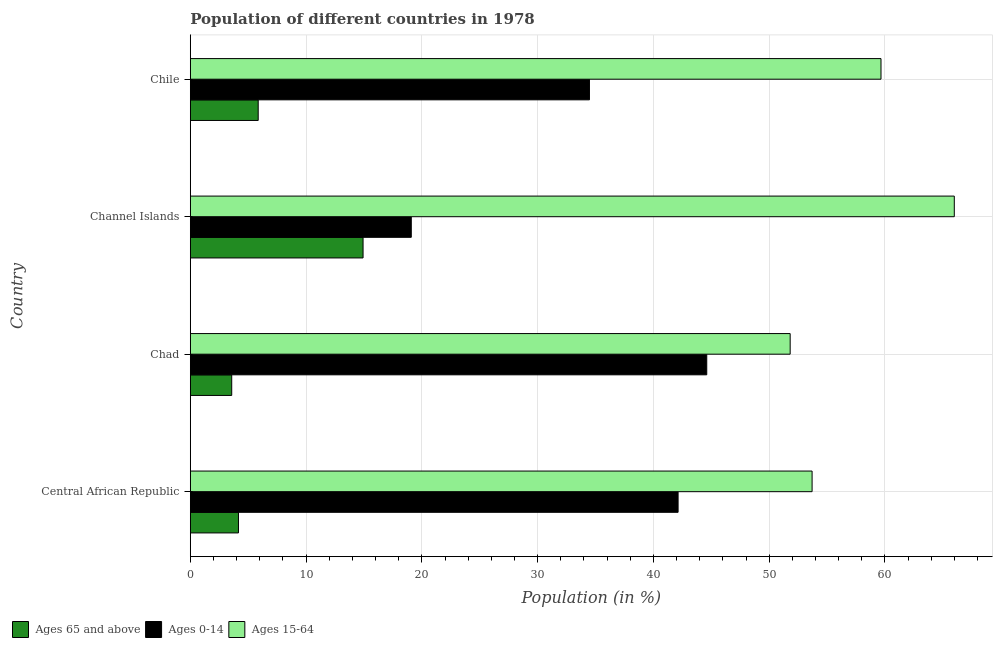How many different coloured bars are there?
Your response must be concise. 3. Are the number of bars per tick equal to the number of legend labels?
Provide a short and direct response. Yes. How many bars are there on the 1st tick from the bottom?
Give a very brief answer. 3. What is the label of the 4th group of bars from the top?
Keep it short and to the point. Central African Republic. In how many cases, is the number of bars for a given country not equal to the number of legend labels?
Make the answer very short. 0. What is the percentage of population within the age-group 15-64 in Chad?
Offer a very short reply. 51.81. Across all countries, what is the maximum percentage of population within the age-group of 65 and above?
Make the answer very short. 14.92. Across all countries, what is the minimum percentage of population within the age-group 15-64?
Offer a terse response. 51.81. In which country was the percentage of population within the age-group of 65 and above maximum?
Offer a very short reply. Channel Islands. In which country was the percentage of population within the age-group of 65 and above minimum?
Offer a terse response. Chad. What is the total percentage of population within the age-group 15-64 in the graph?
Your response must be concise. 231.17. What is the difference between the percentage of population within the age-group 15-64 in Central African Republic and that in Chile?
Offer a terse response. -5.95. What is the difference between the percentage of population within the age-group of 65 and above in Channel Islands and the percentage of population within the age-group 0-14 in Chile?
Provide a short and direct response. -19.55. What is the average percentage of population within the age-group 15-64 per country?
Offer a terse response. 57.79. What is the difference between the percentage of population within the age-group of 65 and above and percentage of population within the age-group 0-14 in Chile?
Give a very brief answer. -28.61. In how many countries, is the percentage of population within the age-group of 65 and above greater than 24 %?
Provide a short and direct response. 0. Is the difference between the percentage of population within the age-group of 65 and above in Chad and Chile greater than the difference between the percentage of population within the age-group 15-64 in Chad and Chile?
Offer a terse response. Yes. What is the difference between the highest and the second highest percentage of population within the age-group of 65 and above?
Give a very brief answer. 9.06. What is the difference between the highest and the lowest percentage of population within the age-group 0-14?
Provide a succinct answer. 25.52. Is the sum of the percentage of population within the age-group 0-14 in Central African Republic and Chile greater than the maximum percentage of population within the age-group of 65 and above across all countries?
Keep it short and to the point. Yes. What does the 1st bar from the top in Chile represents?
Your answer should be very brief. Ages 15-64. What does the 2nd bar from the bottom in Channel Islands represents?
Provide a short and direct response. Ages 0-14. Is it the case that in every country, the sum of the percentage of population within the age-group of 65 and above and percentage of population within the age-group 0-14 is greater than the percentage of population within the age-group 15-64?
Your answer should be compact. No. How many countries are there in the graph?
Provide a short and direct response. 4. Does the graph contain grids?
Your answer should be very brief. Yes. What is the title of the graph?
Offer a terse response. Population of different countries in 1978. Does "Tertiary" appear as one of the legend labels in the graph?
Make the answer very short. No. What is the label or title of the Y-axis?
Your answer should be compact. Country. What is the Population (in %) of Ages 65 and above in Central African Republic?
Your response must be concise. 4.16. What is the Population (in %) in Ages 0-14 in Central African Republic?
Offer a terse response. 42.13. What is the Population (in %) in Ages 15-64 in Central African Republic?
Keep it short and to the point. 53.71. What is the Population (in %) of Ages 65 and above in Chad?
Provide a short and direct response. 3.58. What is the Population (in %) in Ages 0-14 in Chad?
Provide a short and direct response. 44.61. What is the Population (in %) of Ages 15-64 in Chad?
Keep it short and to the point. 51.81. What is the Population (in %) of Ages 65 and above in Channel Islands?
Offer a very short reply. 14.92. What is the Population (in %) of Ages 0-14 in Channel Islands?
Offer a terse response. 19.09. What is the Population (in %) in Ages 15-64 in Channel Islands?
Keep it short and to the point. 65.99. What is the Population (in %) of Ages 65 and above in Chile?
Provide a succinct answer. 5.86. What is the Population (in %) of Ages 0-14 in Chile?
Give a very brief answer. 34.48. What is the Population (in %) in Ages 15-64 in Chile?
Your answer should be very brief. 59.66. Across all countries, what is the maximum Population (in %) of Ages 65 and above?
Your answer should be compact. 14.92. Across all countries, what is the maximum Population (in %) of Ages 0-14?
Your answer should be compact. 44.61. Across all countries, what is the maximum Population (in %) of Ages 15-64?
Your answer should be very brief. 65.99. Across all countries, what is the minimum Population (in %) in Ages 65 and above?
Ensure brevity in your answer.  3.58. Across all countries, what is the minimum Population (in %) of Ages 0-14?
Ensure brevity in your answer.  19.09. Across all countries, what is the minimum Population (in %) of Ages 15-64?
Keep it short and to the point. 51.81. What is the total Population (in %) in Ages 65 and above in the graph?
Give a very brief answer. 28.53. What is the total Population (in %) in Ages 0-14 in the graph?
Your answer should be very brief. 140.31. What is the total Population (in %) in Ages 15-64 in the graph?
Provide a succinct answer. 231.17. What is the difference between the Population (in %) in Ages 65 and above in Central African Republic and that in Chad?
Offer a terse response. 0.58. What is the difference between the Population (in %) in Ages 0-14 in Central African Republic and that in Chad?
Make the answer very short. -2.48. What is the difference between the Population (in %) in Ages 15-64 in Central African Republic and that in Chad?
Ensure brevity in your answer.  1.89. What is the difference between the Population (in %) of Ages 65 and above in Central African Republic and that in Channel Islands?
Provide a succinct answer. -10.76. What is the difference between the Population (in %) in Ages 0-14 in Central African Republic and that in Channel Islands?
Offer a very short reply. 23.04. What is the difference between the Population (in %) in Ages 15-64 in Central African Republic and that in Channel Islands?
Make the answer very short. -12.28. What is the difference between the Population (in %) in Ages 65 and above in Central African Republic and that in Chile?
Your answer should be very brief. -1.7. What is the difference between the Population (in %) in Ages 0-14 in Central African Republic and that in Chile?
Offer a very short reply. 7.66. What is the difference between the Population (in %) of Ages 15-64 in Central African Republic and that in Chile?
Give a very brief answer. -5.95. What is the difference between the Population (in %) in Ages 65 and above in Chad and that in Channel Islands?
Provide a succinct answer. -11.34. What is the difference between the Population (in %) of Ages 0-14 in Chad and that in Channel Islands?
Ensure brevity in your answer.  25.52. What is the difference between the Population (in %) of Ages 15-64 in Chad and that in Channel Islands?
Your answer should be compact. -14.18. What is the difference between the Population (in %) in Ages 65 and above in Chad and that in Chile?
Your answer should be compact. -2.29. What is the difference between the Population (in %) of Ages 0-14 in Chad and that in Chile?
Your answer should be very brief. 10.13. What is the difference between the Population (in %) in Ages 15-64 in Chad and that in Chile?
Provide a short and direct response. -7.85. What is the difference between the Population (in %) of Ages 65 and above in Channel Islands and that in Chile?
Provide a succinct answer. 9.06. What is the difference between the Population (in %) of Ages 0-14 in Channel Islands and that in Chile?
Your response must be concise. -15.39. What is the difference between the Population (in %) of Ages 15-64 in Channel Islands and that in Chile?
Offer a terse response. 6.33. What is the difference between the Population (in %) of Ages 65 and above in Central African Republic and the Population (in %) of Ages 0-14 in Chad?
Offer a terse response. -40.45. What is the difference between the Population (in %) of Ages 65 and above in Central African Republic and the Population (in %) of Ages 15-64 in Chad?
Offer a terse response. -47.65. What is the difference between the Population (in %) in Ages 0-14 in Central African Republic and the Population (in %) in Ages 15-64 in Chad?
Keep it short and to the point. -9.68. What is the difference between the Population (in %) in Ages 65 and above in Central African Republic and the Population (in %) in Ages 0-14 in Channel Islands?
Provide a succinct answer. -14.93. What is the difference between the Population (in %) in Ages 65 and above in Central African Republic and the Population (in %) in Ages 15-64 in Channel Islands?
Your answer should be compact. -61.83. What is the difference between the Population (in %) of Ages 0-14 in Central African Republic and the Population (in %) of Ages 15-64 in Channel Islands?
Make the answer very short. -23.86. What is the difference between the Population (in %) of Ages 65 and above in Central African Republic and the Population (in %) of Ages 0-14 in Chile?
Your answer should be compact. -30.32. What is the difference between the Population (in %) of Ages 65 and above in Central African Republic and the Population (in %) of Ages 15-64 in Chile?
Give a very brief answer. -55.5. What is the difference between the Population (in %) in Ages 0-14 in Central African Republic and the Population (in %) in Ages 15-64 in Chile?
Ensure brevity in your answer.  -17.53. What is the difference between the Population (in %) of Ages 65 and above in Chad and the Population (in %) of Ages 0-14 in Channel Islands?
Make the answer very short. -15.51. What is the difference between the Population (in %) of Ages 65 and above in Chad and the Population (in %) of Ages 15-64 in Channel Islands?
Offer a terse response. -62.41. What is the difference between the Population (in %) in Ages 0-14 in Chad and the Population (in %) in Ages 15-64 in Channel Islands?
Make the answer very short. -21.38. What is the difference between the Population (in %) of Ages 65 and above in Chad and the Population (in %) of Ages 0-14 in Chile?
Give a very brief answer. -30.9. What is the difference between the Population (in %) in Ages 65 and above in Chad and the Population (in %) in Ages 15-64 in Chile?
Give a very brief answer. -56.08. What is the difference between the Population (in %) of Ages 0-14 in Chad and the Population (in %) of Ages 15-64 in Chile?
Your answer should be very brief. -15.05. What is the difference between the Population (in %) of Ages 65 and above in Channel Islands and the Population (in %) of Ages 0-14 in Chile?
Make the answer very short. -19.55. What is the difference between the Population (in %) of Ages 65 and above in Channel Islands and the Population (in %) of Ages 15-64 in Chile?
Your answer should be compact. -44.74. What is the difference between the Population (in %) in Ages 0-14 in Channel Islands and the Population (in %) in Ages 15-64 in Chile?
Give a very brief answer. -40.57. What is the average Population (in %) in Ages 65 and above per country?
Provide a succinct answer. 7.13. What is the average Population (in %) in Ages 0-14 per country?
Give a very brief answer. 35.08. What is the average Population (in %) of Ages 15-64 per country?
Your answer should be very brief. 57.79. What is the difference between the Population (in %) in Ages 65 and above and Population (in %) in Ages 0-14 in Central African Republic?
Make the answer very short. -37.97. What is the difference between the Population (in %) in Ages 65 and above and Population (in %) in Ages 15-64 in Central African Republic?
Ensure brevity in your answer.  -49.55. What is the difference between the Population (in %) in Ages 0-14 and Population (in %) in Ages 15-64 in Central African Republic?
Your answer should be very brief. -11.57. What is the difference between the Population (in %) of Ages 65 and above and Population (in %) of Ages 0-14 in Chad?
Offer a terse response. -41.03. What is the difference between the Population (in %) in Ages 65 and above and Population (in %) in Ages 15-64 in Chad?
Give a very brief answer. -48.23. What is the difference between the Population (in %) in Ages 0-14 and Population (in %) in Ages 15-64 in Chad?
Ensure brevity in your answer.  -7.2. What is the difference between the Population (in %) in Ages 65 and above and Population (in %) in Ages 0-14 in Channel Islands?
Make the answer very short. -4.17. What is the difference between the Population (in %) in Ages 65 and above and Population (in %) in Ages 15-64 in Channel Islands?
Offer a very short reply. -51.07. What is the difference between the Population (in %) in Ages 0-14 and Population (in %) in Ages 15-64 in Channel Islands?
Your answer should be compact. -46.9. What is the difference between the Population (in %) of Ages 65 and above and Population (in %) of Ages 0-14 in Chile?
Your answer should be very brief. -28.61. What is the difference between the Population (in %) of Ages 65 and above and Population (in %) of Ages 15-64 in Chile?
Your response must be concise. -53.79. What is the difference between the Population (in %) in Ages 0-14 and Population (in %) in Ages 15-64 in Chile?
Give a very brief answer. -25.18. What is the ratio of the Population (in %) in Ages 65 and above in Central African Republic to that in Chad?
Offer a terse response. 1.16. What is the ratio of the Population (in %) of Ages 0-14 in Central African Republic to that in Chad?
Your answer should be very brief. 0.94. What is the ratio of the Population (in %) of Ages 15-64 in Central African Republic to that in Chad?
Provide a succinct answer. 1.04. What is the ratio of the Population (in %) in Ages 65 and above in Central African Republic to that in Channel Islands?
Your answer should be very brief. 0.28. What is the ratio of the Population (in %) in Ages 0-14 in Central African Republic to that in Channel Islands?
Your answer should be compact. 2.21. What is the ratio of the Population (in %) of Ages 15-64 in Central African Republic to that in Channel Islands?
Make the answer very short. 0.81. What is the ratio of the Population (in %) of Ages 65 and above in Central African Republic to that in Chile?
Keep it short and to the point. 0.71. What is the ratio of the Population (in %) in Ages 0-14 in Central African Republic to that in Chile?
Provide a succinct answer. 1.22. What is the ratio of the Population (in %) in Ages 15-64 in Central African Republic to that in Chile?
Your response must be concise. 0.9. What is the ratio of the Population (in %) in Ages 65 and above in Chad to that in Channel Islands?
Your answer should be very brief. 0.24. What is the ratio of the Population (in %) of Ages 0-14 in Chad to that in Channel Islands?
Your answer should be compact. 2.34. What is the ratio of the Population (in %) of Ages 15-64 in Chad to that in Channel Islands?
Your answer should be compact. 0.79. What is the ratio of the Population (in %) in Ages 65 and above in Chad to that in Chile?
Provide a short and direct response. 0.61. What is the ratio of the Population (in %) of Ages 0-14 in Chad to that in Chile?
Offer a terse response. 1.29. What is the ratio of the Population (in %) in Ages 15-64 in Chad to that in Chile?
Offer a terse response. 0.87. What is the ratio of the Population (in %) of Ages 65 and above in Channel Islands to that in Chile?
Provide a succinct answer. 2.54. What is the ratio of the Population (in %) of Ages 0-14 in Channel Islands to that in Chile?
Your response must be concise. 0.55. What is the ratio of the Population (in %) of Ages 15-64 in Channel Islands to that in Chile?
Provide a succinct answer. 1.11. What is the difference between the highest and the second highest Population (in %) in Ages 65 and above?
Offer a very short reply. 9.06. What is the difference between the highest and the second highest Population (in %) in Ages 0-14?
Provide a succinct answer. 2.48. What is the difference between the highest and the second highest Population (in %) in Ages 15-64?
Make the answer very short. 6.33. What is the difference between the highest and the lowest Population (in %) in Ages 65 and above?
Make the answer very short. 11.34. What is the difference between the highest and the lowest Population (in %) in Ages 0-14?
Make the answer very short. 25.52. What is the difference between the highest and the lowest Population (in %) of Ages 15-64?
Make the answer very short. 14.18. 